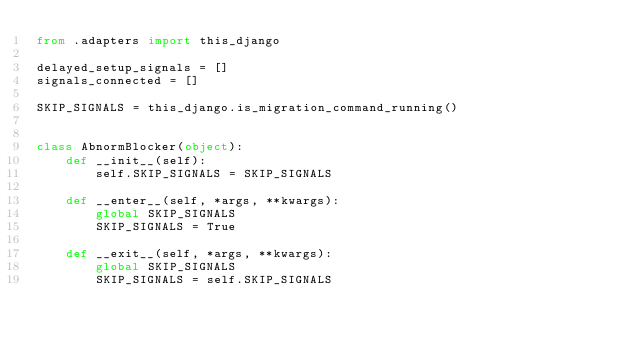<code> <loc_0><loc_0><loc_500><loc_500><_Python_>from .adapters import this_django

delayed_setup_signals = []
signals_connected = []

SKIP_SIGNALS = this_django.is_migration_command_running()


class AbnormBlocker(object):
    def __init__(self):
        self.SKIP_SIGNALS = SKIP_SIGNALS

    def __enter__(self, *args, **kwargs):
        global SKIP_SIGNALS
        SKIP_SIGNALS = True

    def __exit__(self, *args, **kwargs):
        global SKIP_SIGNALS
        SKIP_SIGNALS = self.SKIP_SIGNALS
</code> 